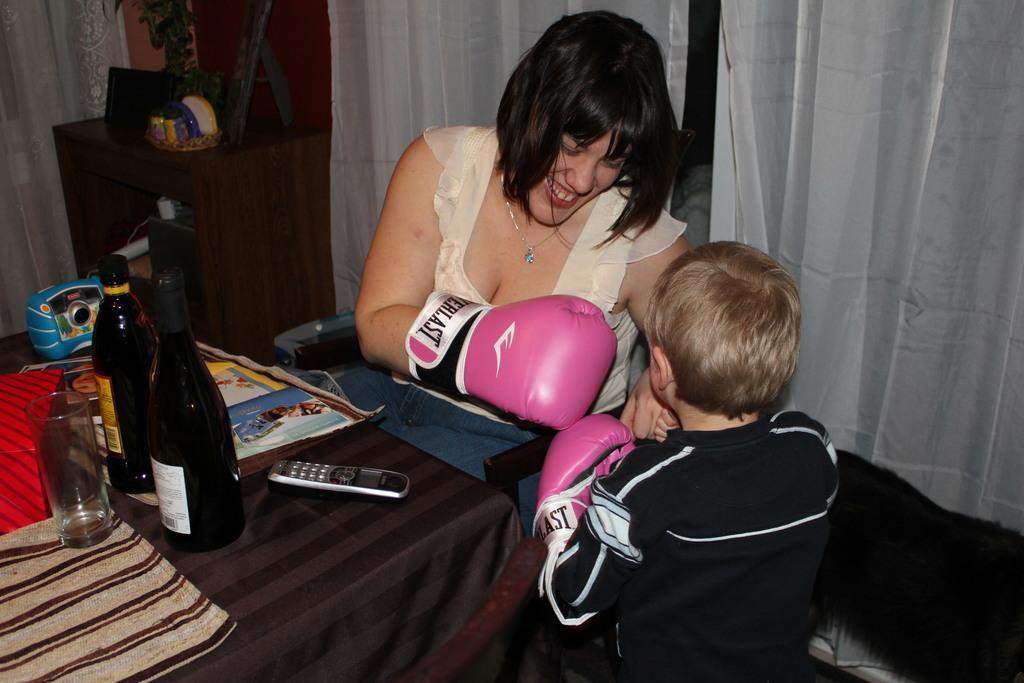In one or two sentences, can you explain what this image depicts? In this image i can see a woman sitting and smiling there is a kid in front of her, there are two bottles, a glass , a remote and a paper on a table at the back ground i can see a small pot on a cupboard, a wall and a curtain. 